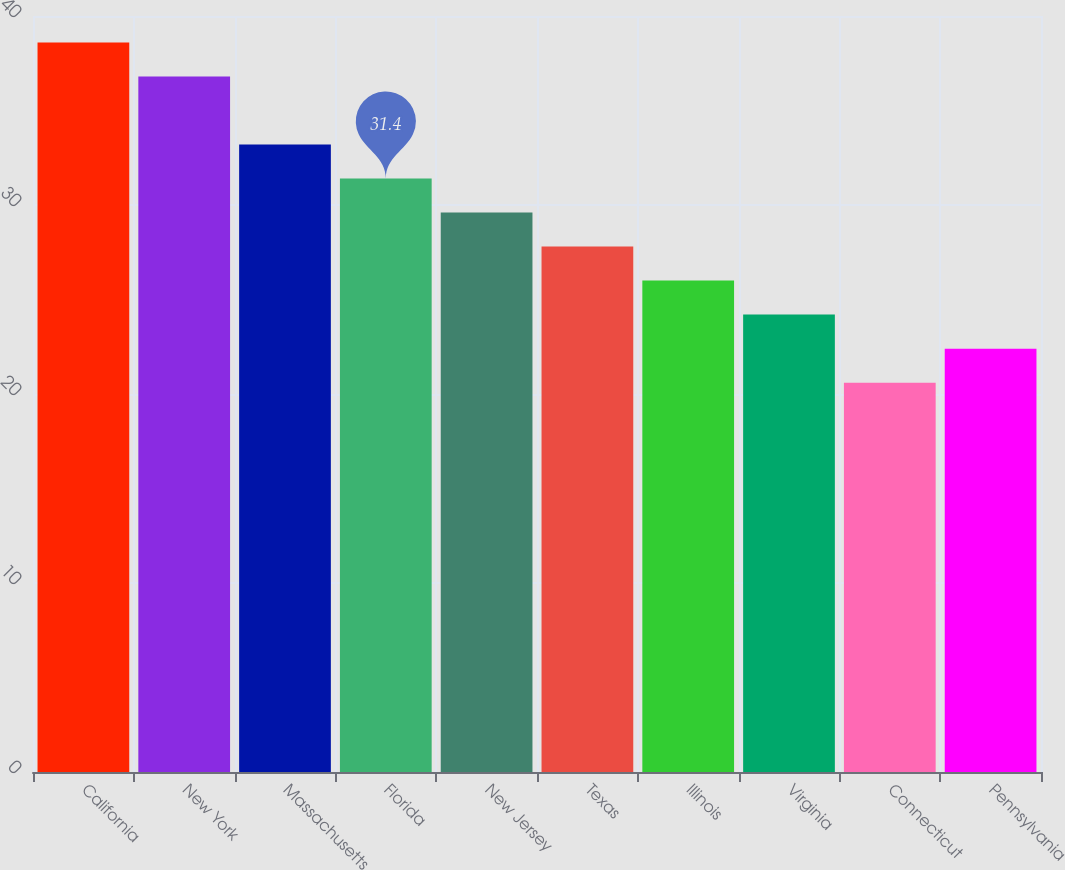Convert chart to OTSL. <chart><loc_0><loc_0><loc_500><loc_500><bar_chart><fcel>California<fcel>New York<fcel>Massachusetts<fcel>Florida<fcel>New Jersey<fcel>Texas<fcel>Illinois<fcel>Virginia<fcel>Connecticut<fcel>Pennsylvania<nl><fcel>38.6<fcel>36.8<fcel>33.2<fcel>31.4<fcel>29.6<fcel>27.8<fcel>26<fcel>24.2<fcel>20.6<fcel>22.4<nl></chart> 